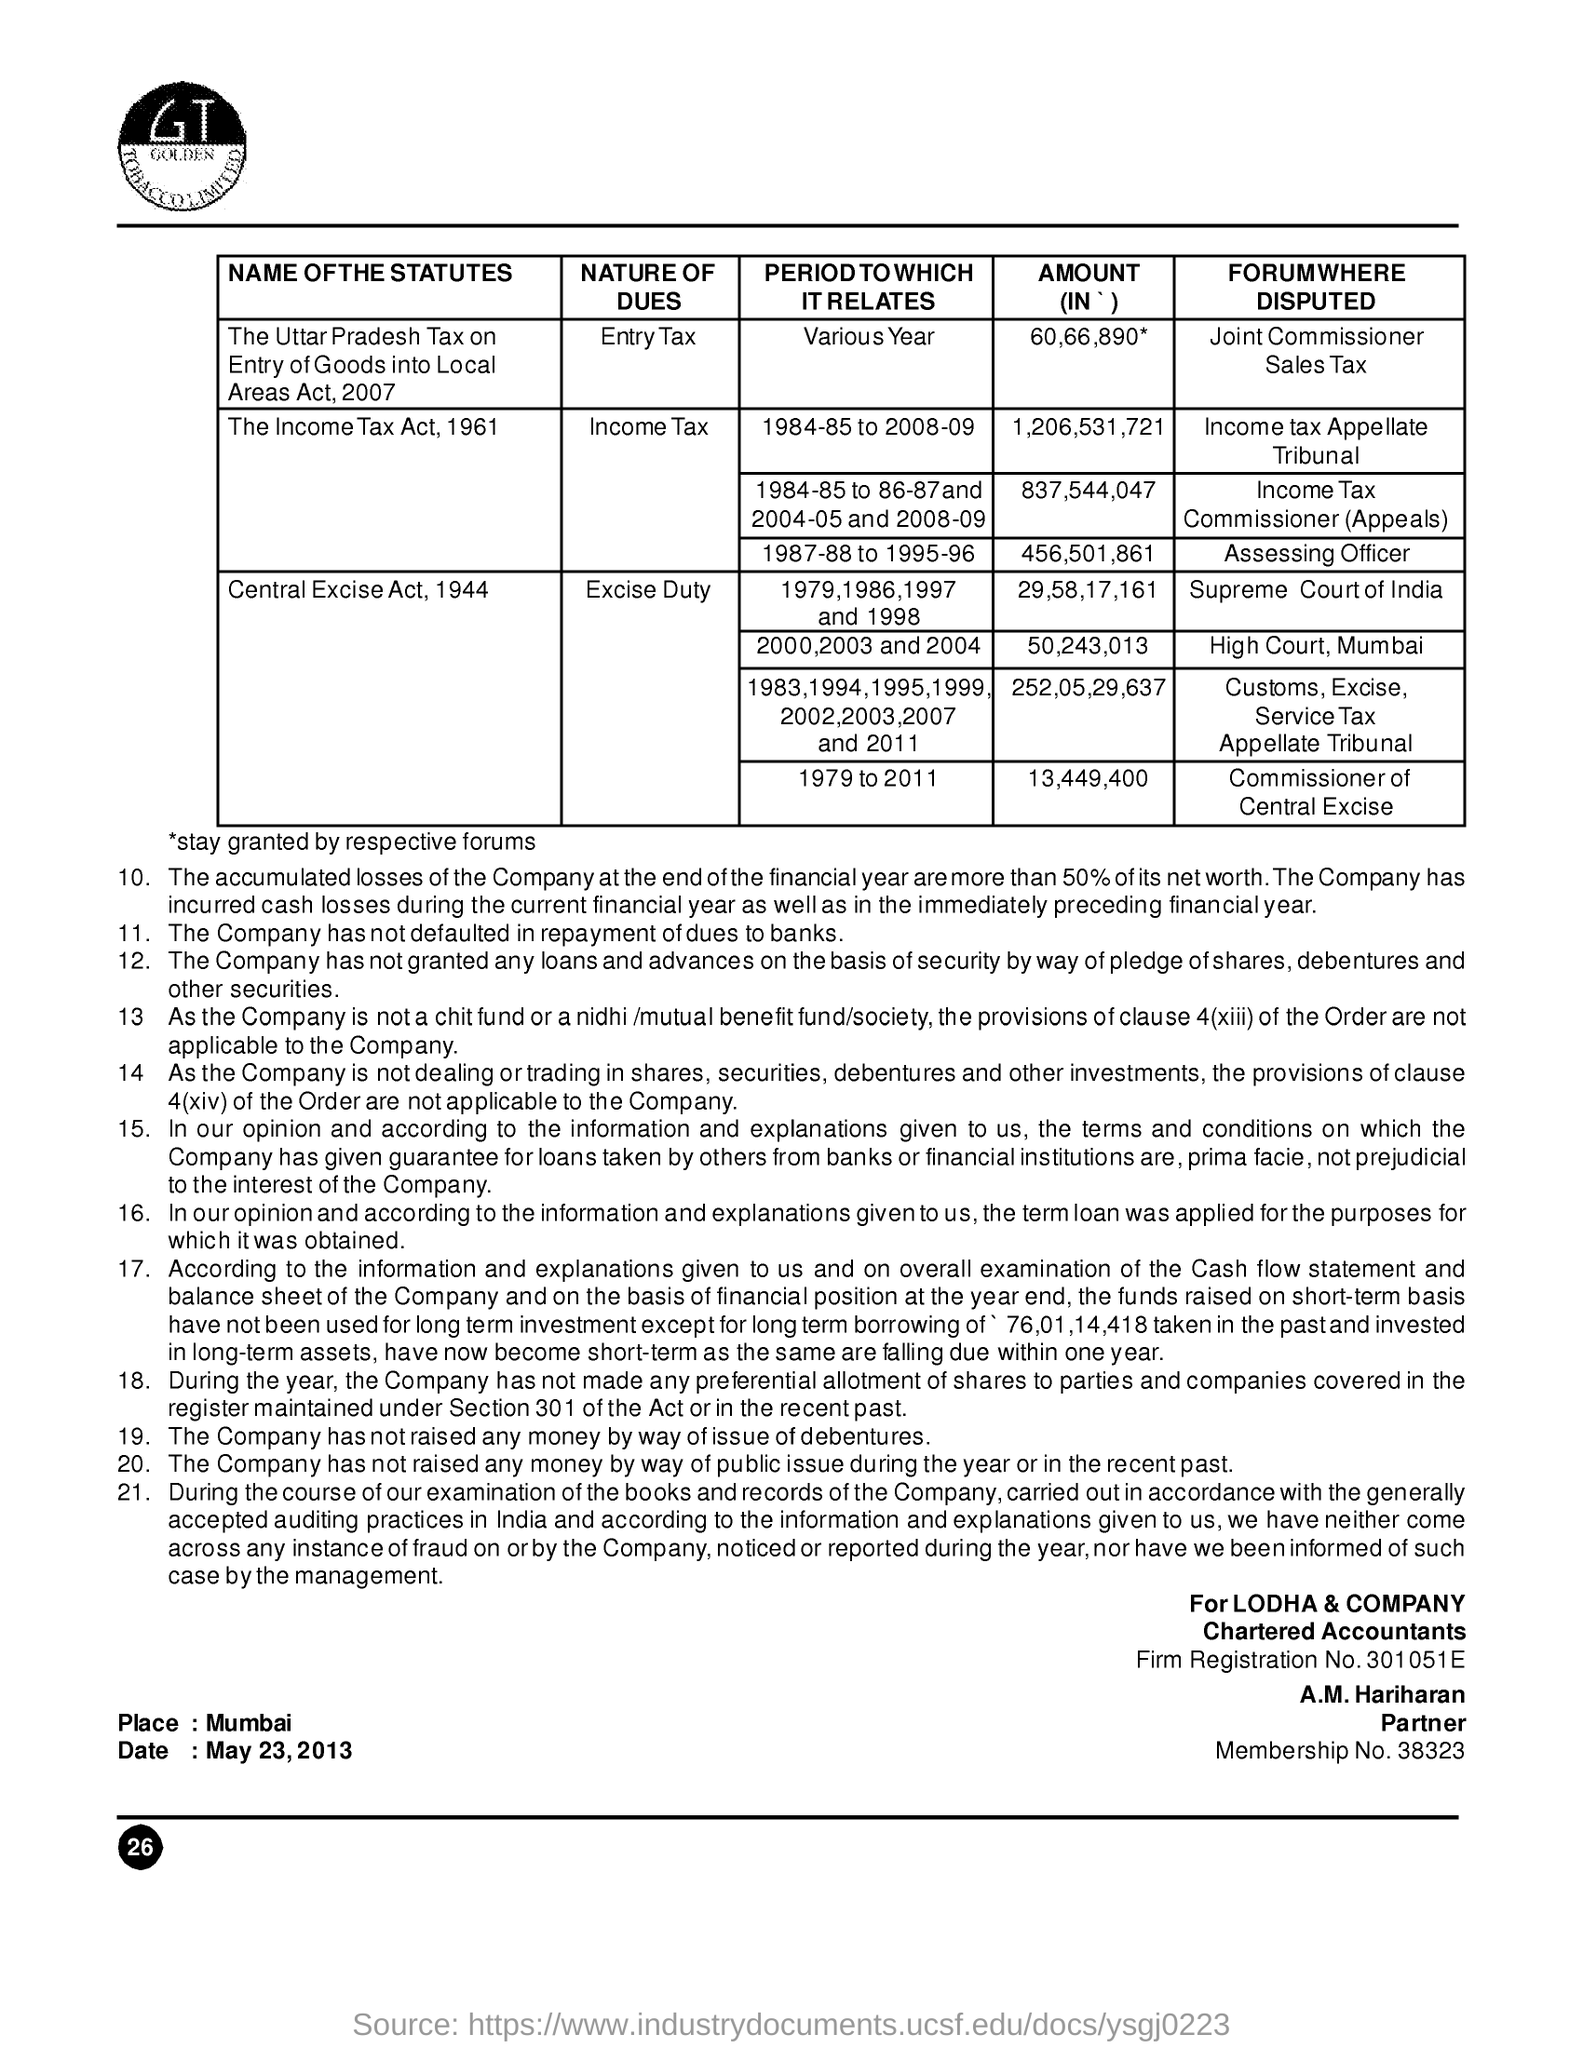What is the date mentioned ?
Provide a short and direct response. May 23, 2013. What is the  place name mentioned
Keep it short and to the point. Mumbai. What is the name of the partner ?
Your answer should be very brief. A.m. hariharan. What is the firm registration no ?
Offer a very short reply. 301051E. What is the membership no?
Your response must be concise. 38323. What is the amount of income tax act , 1961 forum disputed from assessing officer
Offer a very short reply. 456,501,861. What is the nature of dues for central excise act , 1994
Give a very brief answer. Excise  duty. What is the amount of central excise act , 1994 forum distributed form supreme court of india
Give a very brief answer. 29,58,17,161. What is the amount of central excise act , 1994 forum distributed form high court , mumbai
Offer a very short reply. 50,243,013. 